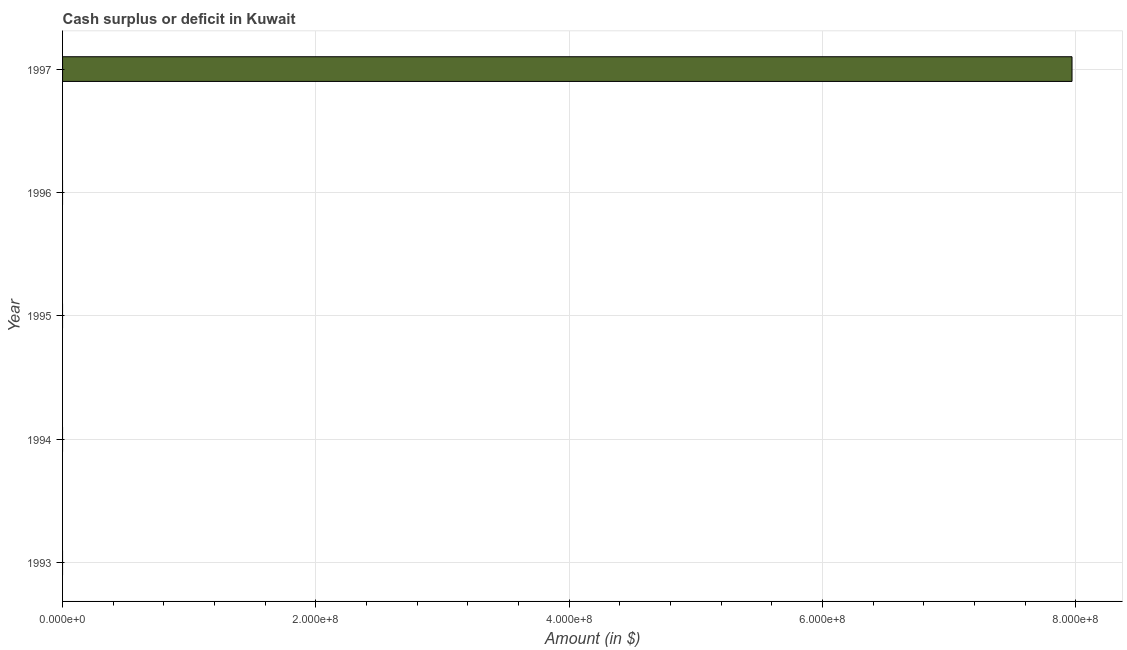Does the graph contain any zero values?
Keep it short and to the point. Yes. What is the title of the graph?
Make the answer very short. Cash surplus or deficit in Kuwait. What is the label or title of the X-axis?
Your response must be concise. Amount (in $). What is the cash surplus or deficit in 1993?
Keep it short and to the point. 0. Across all years, what is the maximum cash surplus or deficit?
Offer a terse response. 7.97e+08. In which year was the cash surplus or deficit maximum?
Ensure brevity in your answer.  1997. What is the sum of the cash surplus or deficit?
Give a very brief answer. 7.97e+08. What is the average cash surplus or deficit per year?
Ensure brevity in your answer.  1.59e+08. What is the median cash surplus or deficit?
Offer a very short reply. 0. What is the difference between the highest and the lowest cash surplus or deficit?
Ensure brevity in your answer.  7.97e+08. Are all the bars in the graph horizontal?
Your response must be concise. Yes. What is the difference between two consecutive major ticks on the X-axis?
Offer a very short reply. 2.00e+08. Are the values on the major ticks of X-axis written in scientific E-notation?
Offer a very short reply. Yes. What is the Amount (in $) in 1994?
Your answer should be compact. 0. What is the Amount (in $) of 1995?
Your answer should be very brief. 0. What is the Amount (in $) of 1996?
Your answer should be very brief. 0. What is the Amount (in $) in 1997?
Your response must be concise. 7.97e+08. 